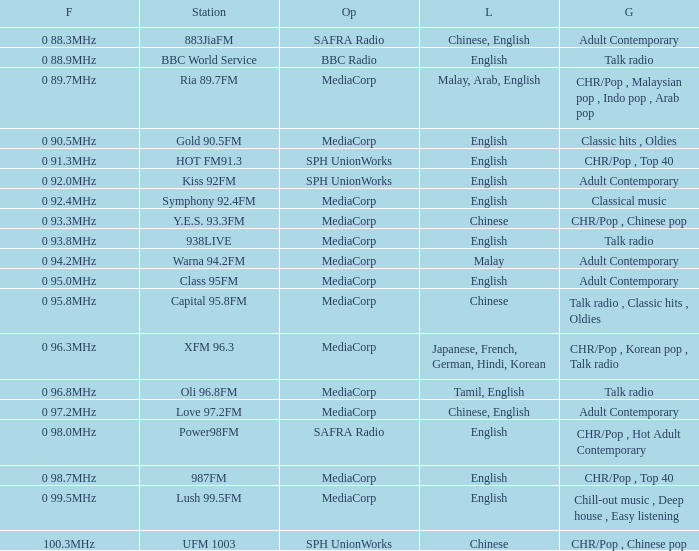What is the genre of the BBC World Service? Talk radio. 